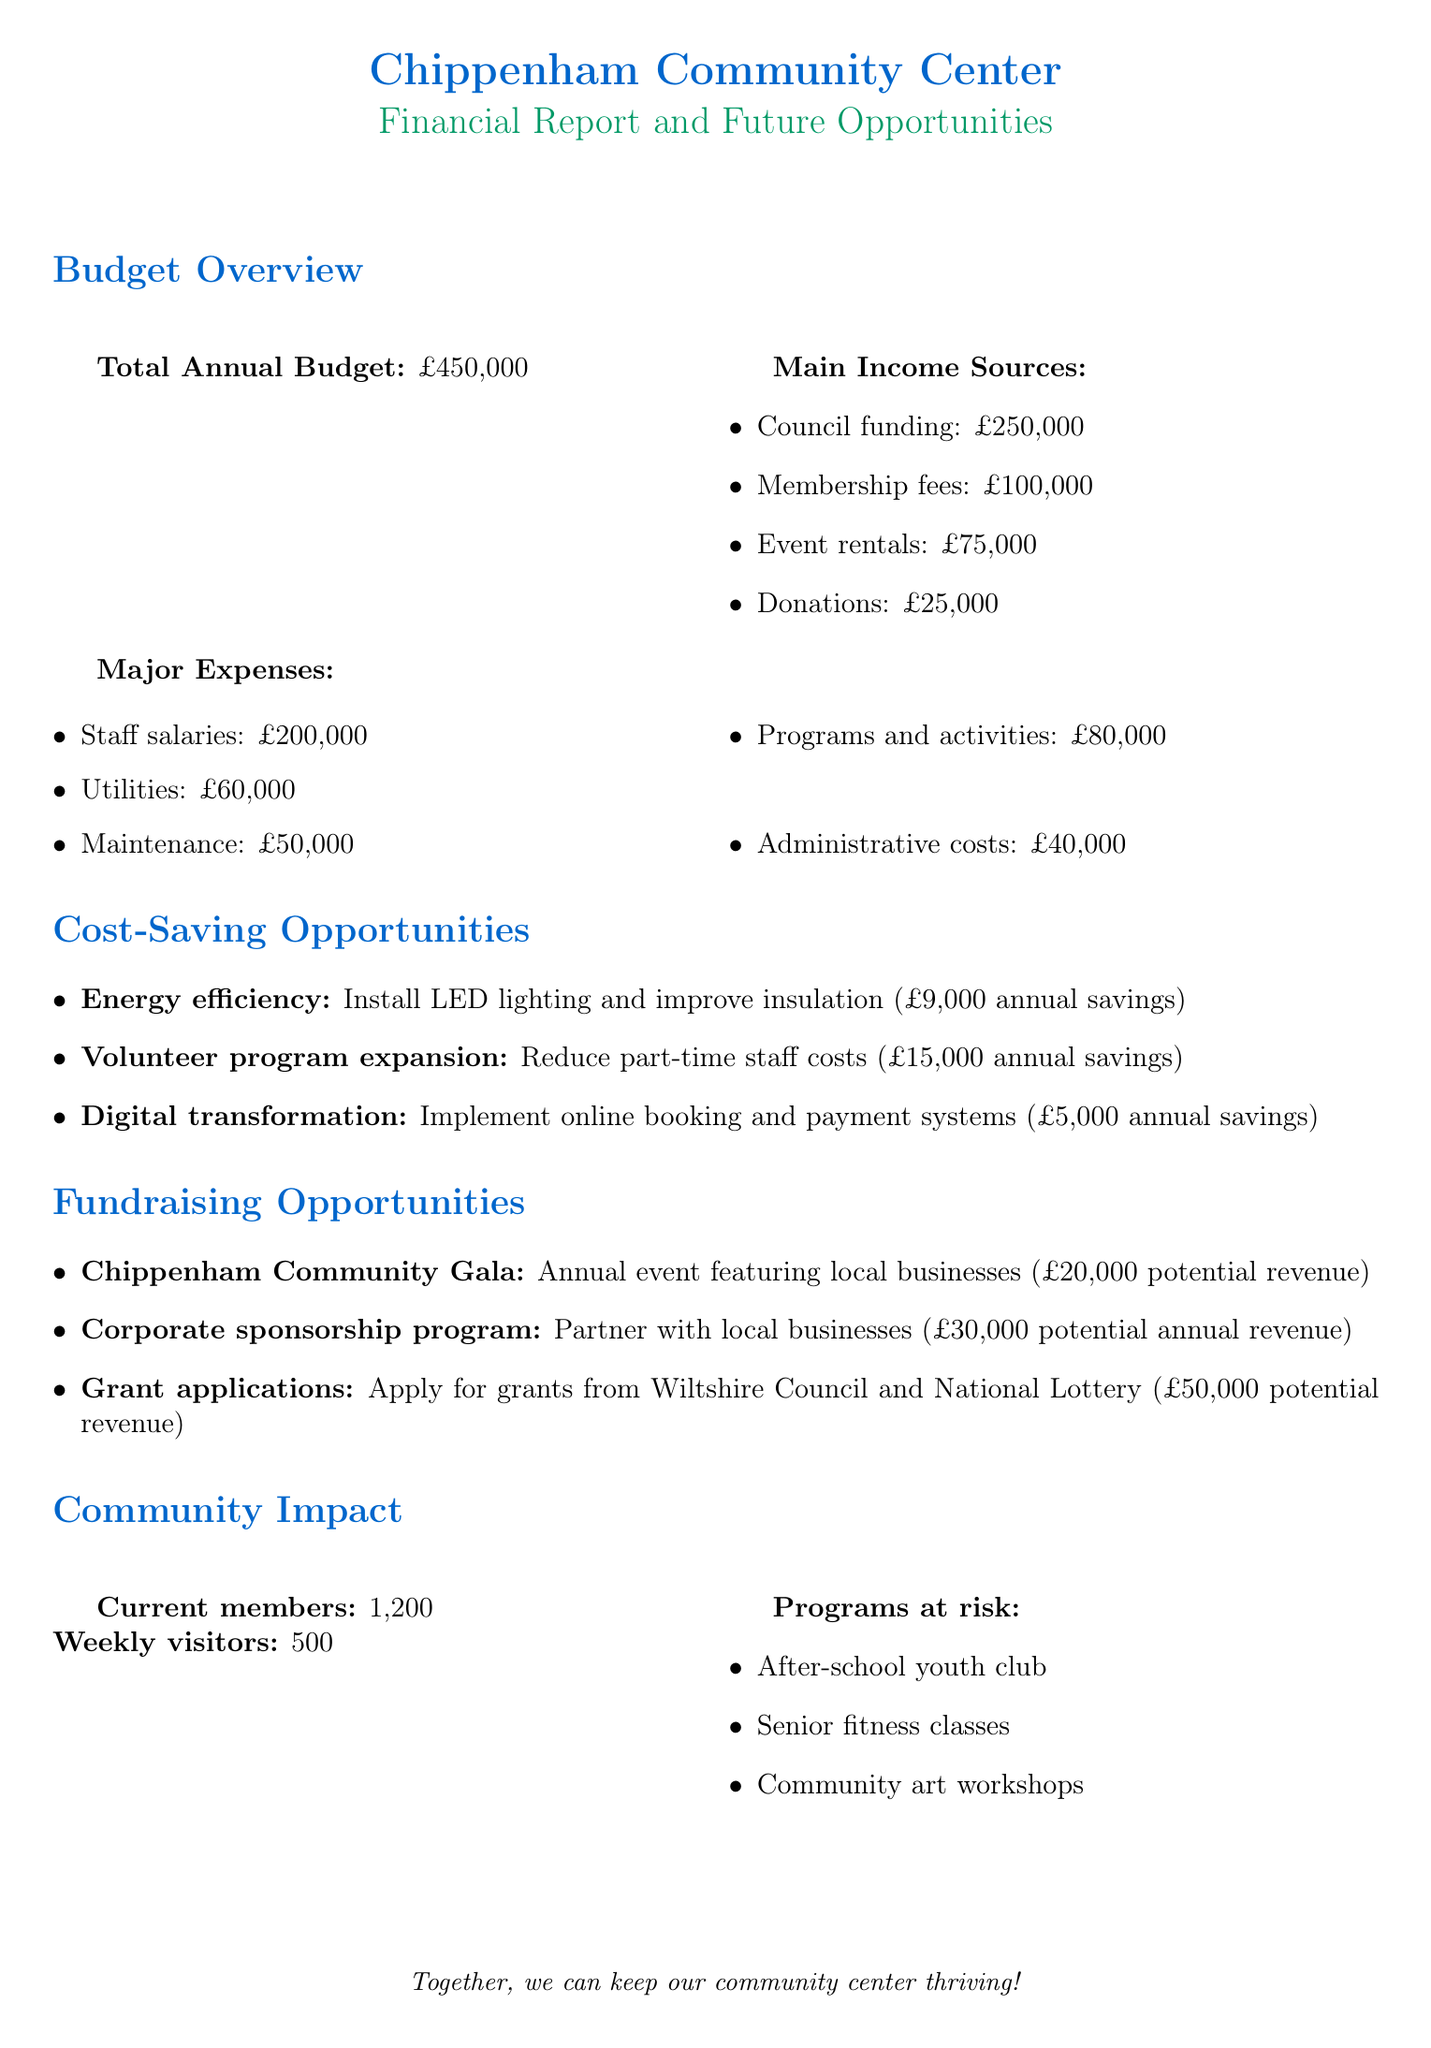What is the total annual budget? The total annual budget is provided in the budget overview section of the document.
Answer: £450,000 How much funding comes from council? The council funding figure is listed among the main income sources in the document.
Answer: £250,000 What are the potential savings from digital transformation? The potential savings from digital transformation is detailed in the cost-saving opportunities section.
Answer: £5,000 annually How many current members does the community center have? The number of current members is stated in the community impact section of the document.
Answer: 1,200 What is the potential revenue from grant applications? The potential revenue figure from grant applications is specified under fundraising opportunities.
Answer: £50,000 Which program is at risk that serves seniors? One of the programs at risk listed in the community impact section specifically serves seniors.
Answer: Senior fitness classes What is one fundraising initiative mentioned in the report? Examples of fundraising initiatives are provided in the fundraising opportunities section.
Answer: Chippenham Community Gala What is the total potential revenue from corporate sponsorship? The total potential revenue figure from corporate sponsorship is given in the fundraising opportunities section.
Answer: £30,000 annually 